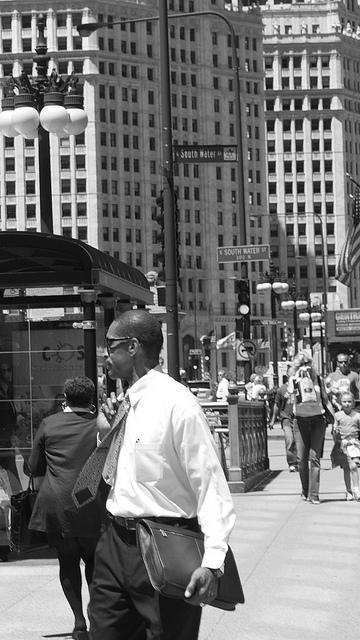What does the fenced in area behind the man lead to?
Make your selection from the four choices given to correctly answer the question.
Options: Subway, park, jail, deli. Subway. 